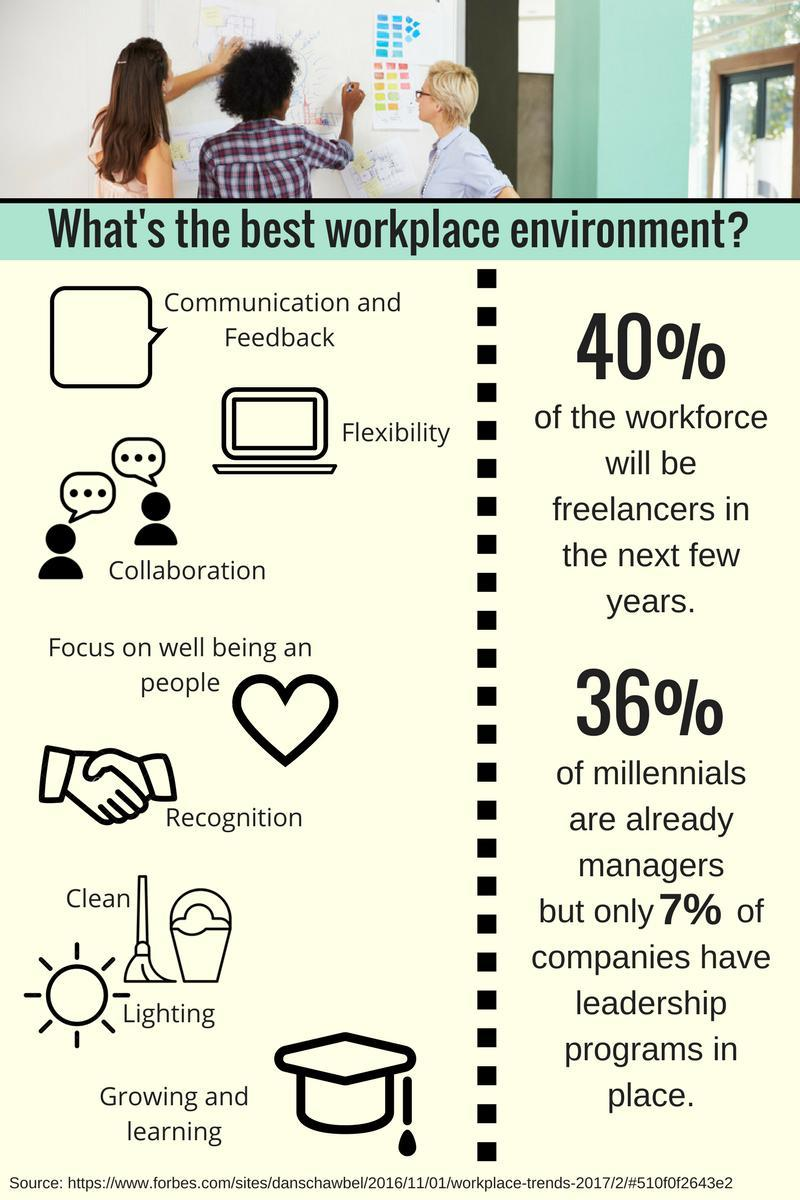What percentage of millennials are not managers?
Answer the question with a short phrase. 60% What percentage of companies have no leadership programs in place? 93% How many qualities of a workplace mentioned in this infographic? 8 